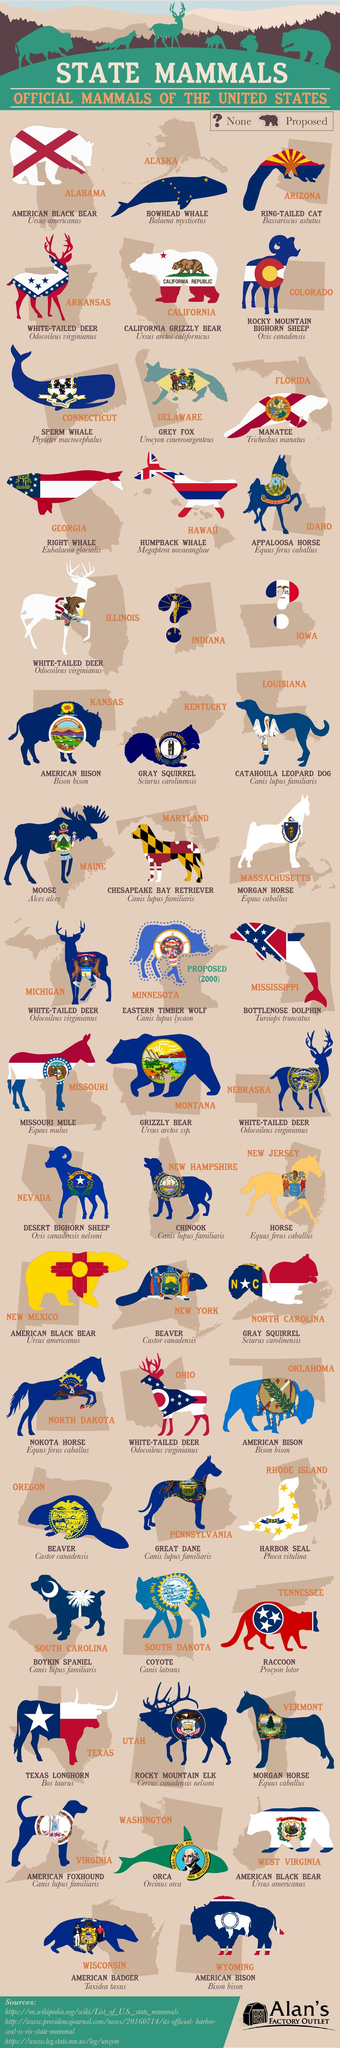Point out several critical features in this image. The scientific name of the mammal Bowhead Whale is Balaena mysticetus. I, [Your Name], hereby declare that the official mammal of the State of New Jersey is the Horse. The scientific name of the mammal Orca is Orcinus Orca. Vermont has officially designated the Morgan Horse as its state mammal. The official mammal of the state of Florida is the manatee. 